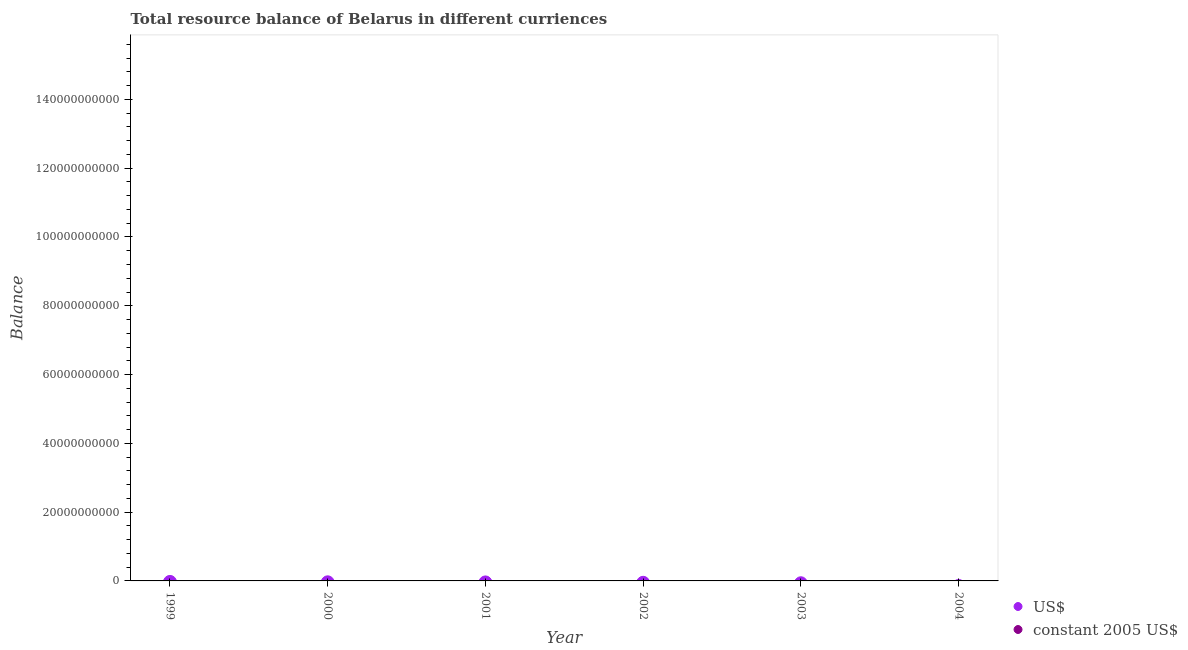What is the resource balance in constant us$ in 2001?
Give a very brief answer. 0. In how many years, is the resource balance in constant us$ greater than the average resource balance in constant us$ taken over all years?
Keep it short and to the point. 0. Does the resource balance in us$ monotonically increase over the years?
Provide a short and direct response. No. Is the resource balance in constant us$ strictly less than the resource balance in us$ over the years?
Provide a succinct answer. Yes. How many dotlines are there?
Provide a succinct answer. 0. How many years are there in the graph?
Your answer should be very brief. 6. Does the graph contain any zero values?
Offer a terse response. Yes. Does the graph contain grids?
Give a very brief answer. No. Where does the legend appear in the graph?
Your response must be concise. Bottom right. How are the legend labels stacked?
Offer a very short reply. Vertical. What is the title of the graph?
Your answer should be very brief. Total resource balance of Belarus in different curriences. Does "Fraud firms" appear as one of the legend labels in the graph?
Your response must be concise. No. What is the label or title of the Y-axis?
Your response must be concise. Balance. What is the Balance in US$ in 2000?
Provide a succinct answer. 0. What is the Balance in constant 2005 US$ in 2000?
Provide a short and direct response. 0. What is the Balance in US$ in 2002?
Your answer should be compact. 0. What is the Balance of US$ in 2003?
Offer a terse response. 0. What is the Balance of constant 2005 US$ in 2003?
Your response must be concise. 0. What is the Balance in US$ in 2004?
Your answer should be compact. 0. What is the Balance of constant 2005 US$ in 2004?
Your answer should be very brief. 0. What is the total Balance of US$ in the graph?
Your response must be concise. 0. What is the average Balance of US$ per year?
Provide a succinct answer. 0. 